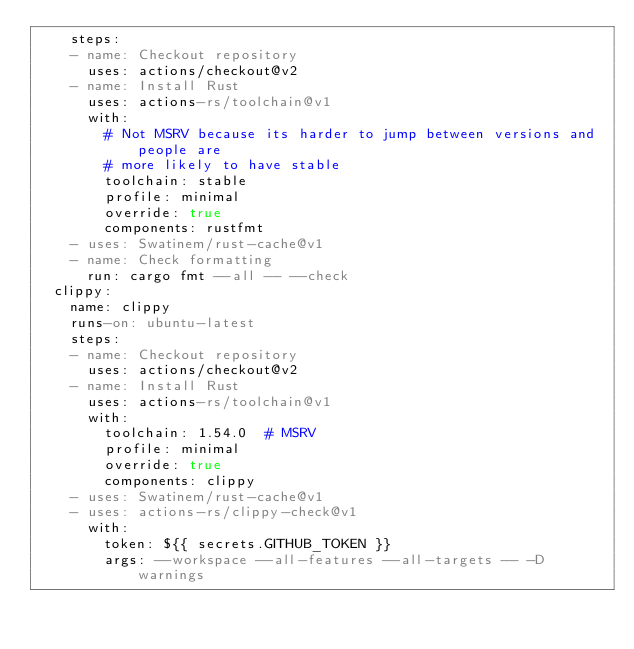Convert code to text. <code><loc_0><loc_0><loc_500><loc_500><_YAML_>    steps:
    - name: Checkout repository
      uses: actions/checkout@v2
    - name: Install Rust
      uses: actions-rs/toolchain@v1
      with:
        # Not MSRV because its harder to jump between versions and people are
        # more likely to have stable
        toolchain: stable
        profile: minimal
        override: true
        components: rustfmt
    - uses: Swatinem/rust-cache@v1
    - name: Check formatting
      run: cargo fmt --all -- --check
  clippy:
    name: clippy
    runs-on: ubuntu-latest
    steps:
    - name: Checkout repository
      uses: actions/checkout@v2
    - name: Install Rust
      uses: actions-rs/toolchain@v1
      with:
        toolchain: 1.54.0  # MSRV
        profile: minimal
        override: true
        components: clippy
    - uses: Swatinem/rust-cache@v1
    - uses: actions-rs/clippy-check@v1
      with:
        token: ${{ secrets.GITHUB_TOKEN }}
        args: --workspace --all-features --all-targets -- -D warnings
</code> 